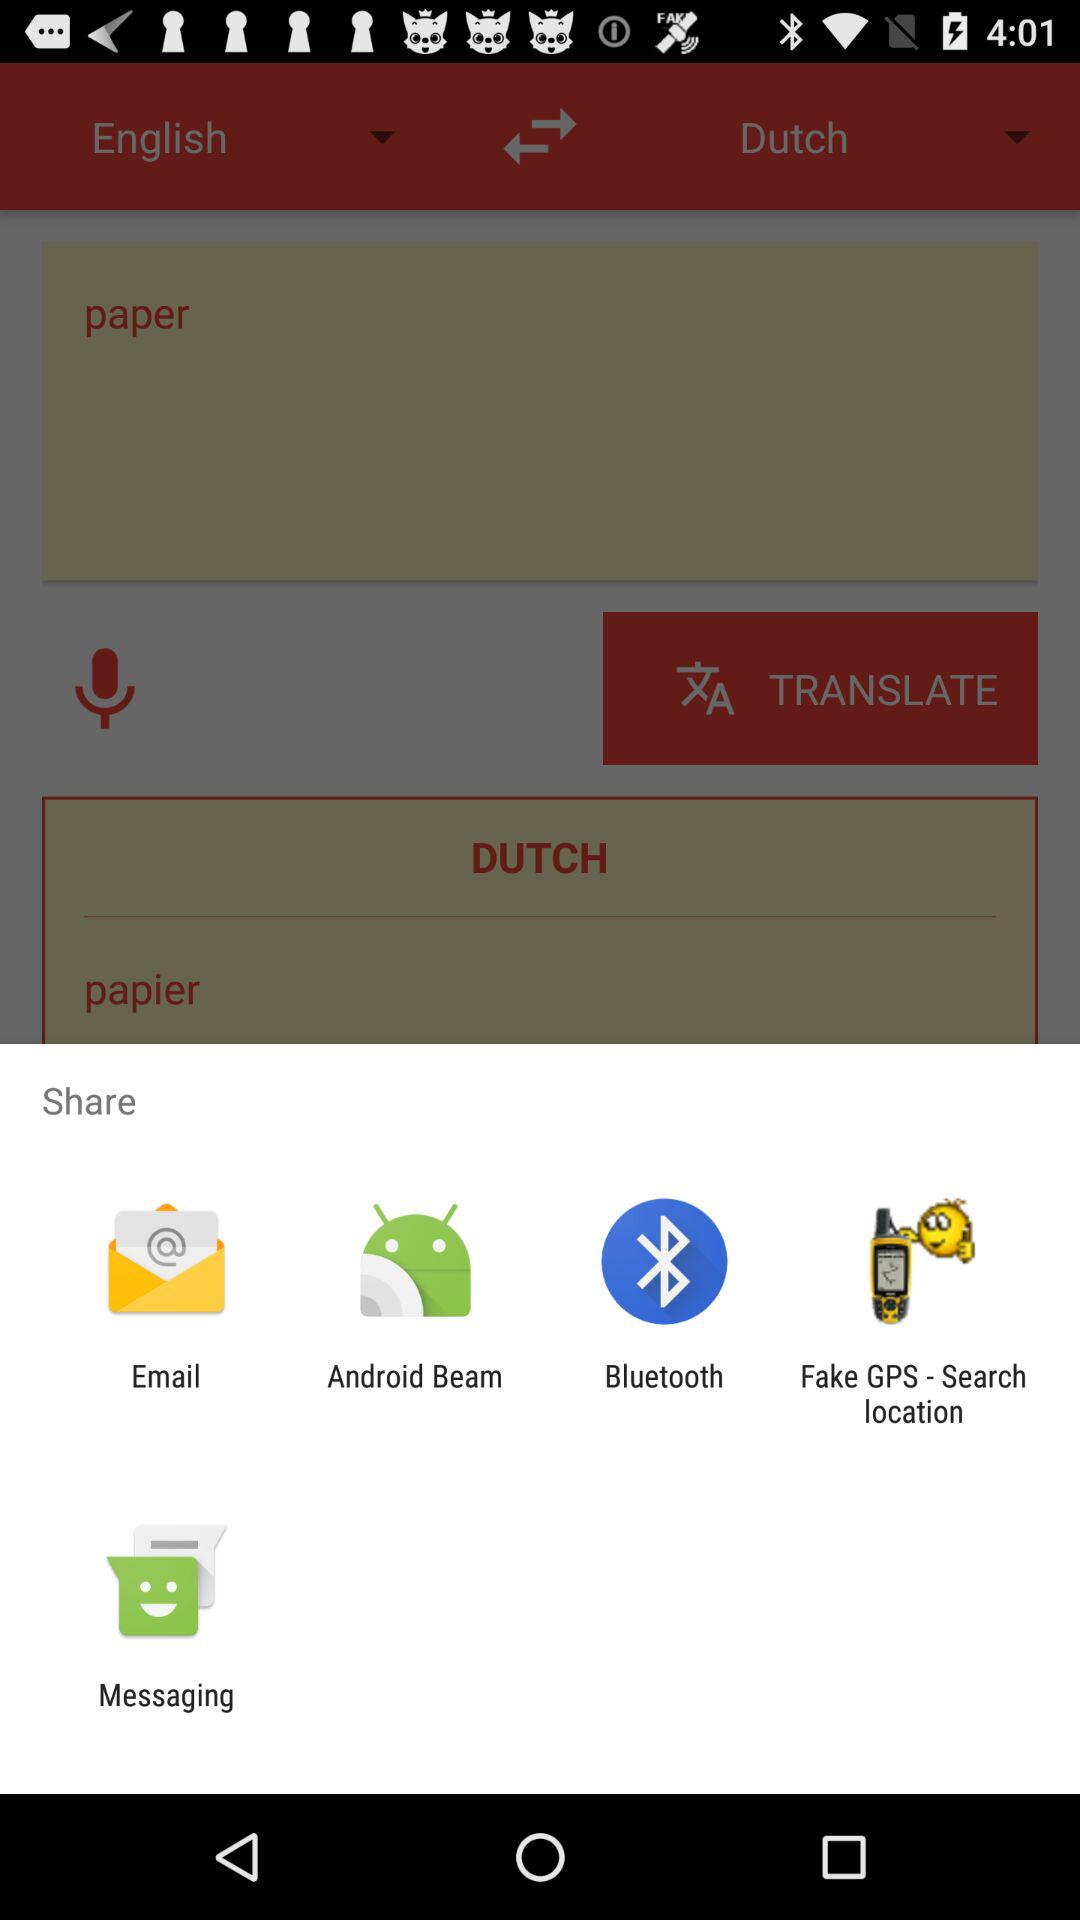What are the different options available to share? The different available options to share are "Email", "Android Beam", "Bluetooth", "Fake GPS - Search location" and "Messaging". 